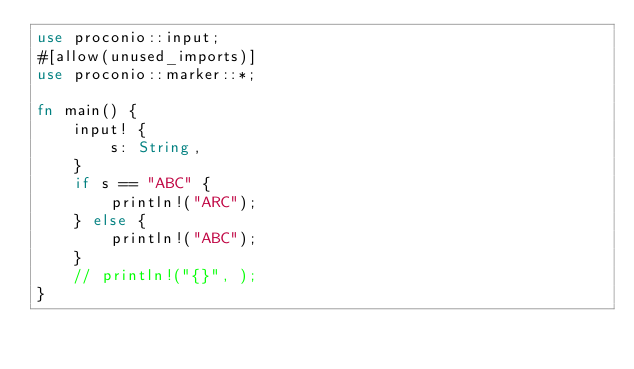<code> <loc_0><loc_0><loc_500><loc_500><_Rust_>use proconio::input;
#[allow(unused_imports)]
use proconio::marker::*;

fn main() {
    input! {
        s: String,
    }
    if s == "ABC" {
        println!("ARC");
    } else {
        println!("ABC");
    }
    // println!("{}", );
}
</code> 